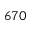Convert formula to latex. <formula><loc_0><loc_0><loc_500><loc_500>6 7 0</formula> 